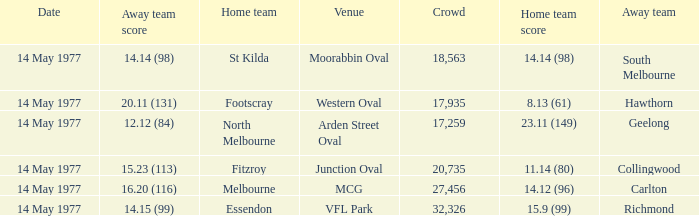Name the away team for essendon Richmond. 